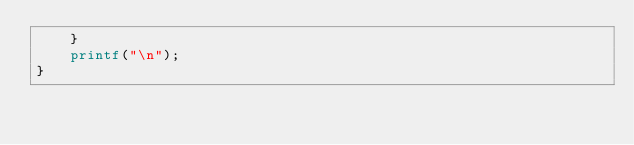<code> <loc_0><loc_0><loc_500><loc_500><_Awk_>	}
	printf("\n");
}
</code> 